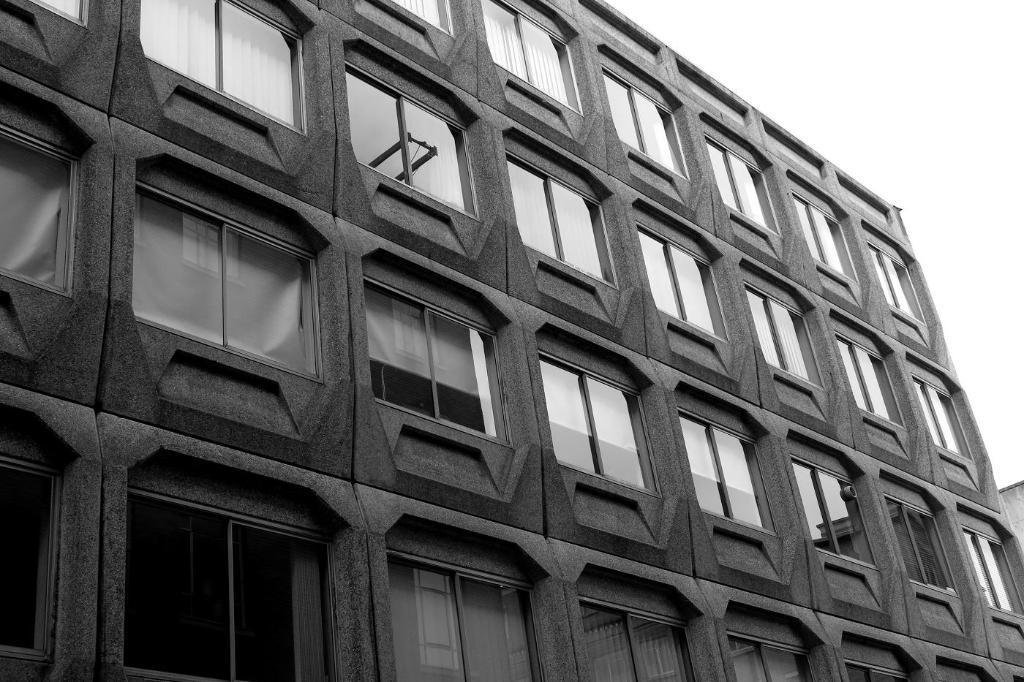Could you give a brief overview of what you see in this image? This is a black and white image. In this image we can see building. In the background there is sky. 